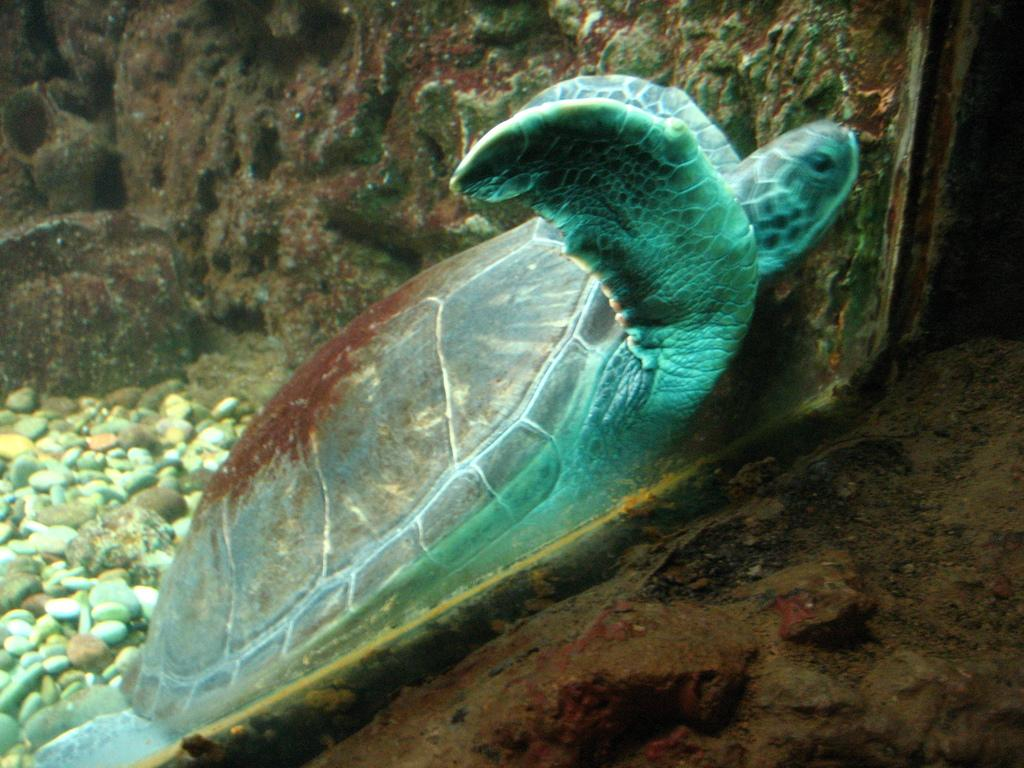What type of animal is in the picture? There is a tortoise in the picture. What else can be seen in the picture besides the tortoise? There are stones in the picture. Is there any barrier or enclosure visible in the picture? Yes, there is a glass wall in the picture. How many chairs are placed around the tortoise in the picture? There are no chairs present in the image. 